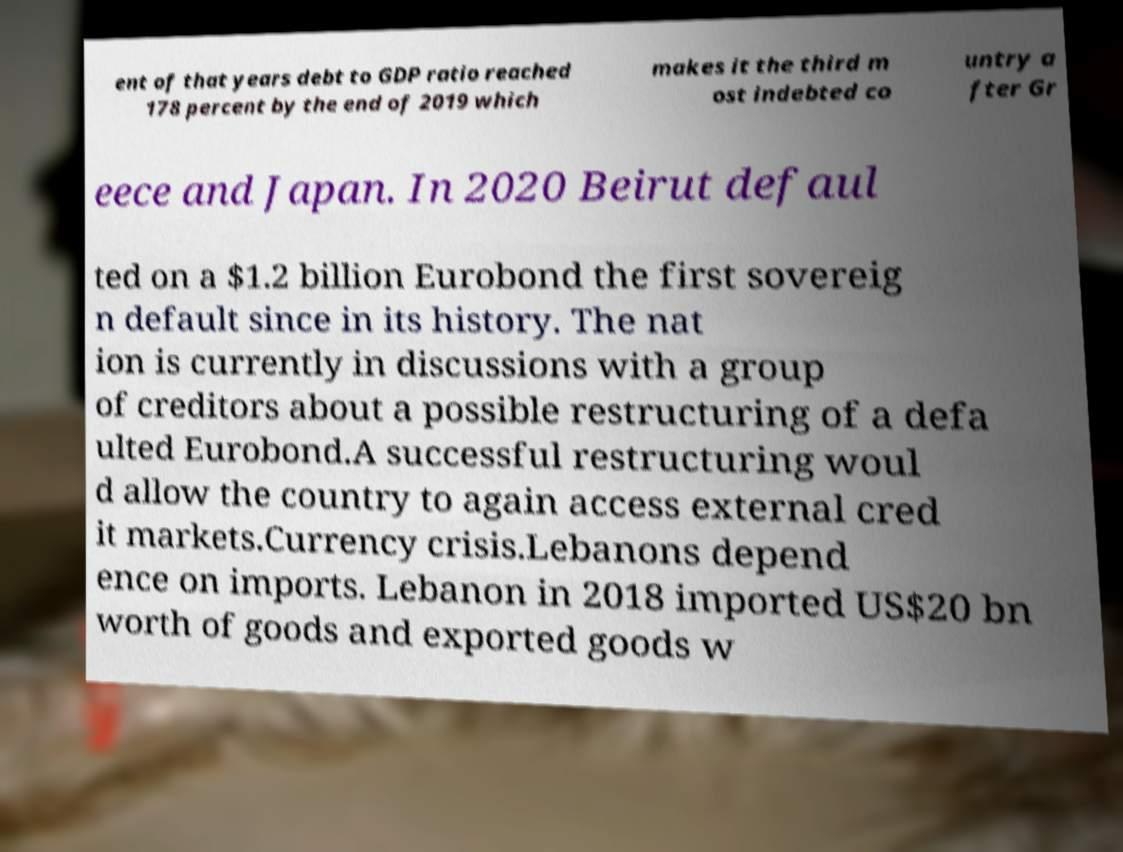Please read and relay the text visible in this image. What does it say? ent of that years debt to GDP ratio reached 178 percent by the end of 2019 which makes it the third m ost indebted co untry a fter Gr eece and Japan. In 2020 Beirut defaul ted on a $1.2 billion Eurobond the first sovereig n default since in its history. The nat ion is currently in discussions with a group of creditors about a possible restructuring of a defa ulted Eurobond.A successful restructuring woul d allow the country to again access external cred it markets.Currency crisis.Lebanons depend ence on imports. Lebanon in 2018 imported US$20 bn worth of goods and exported goods w 